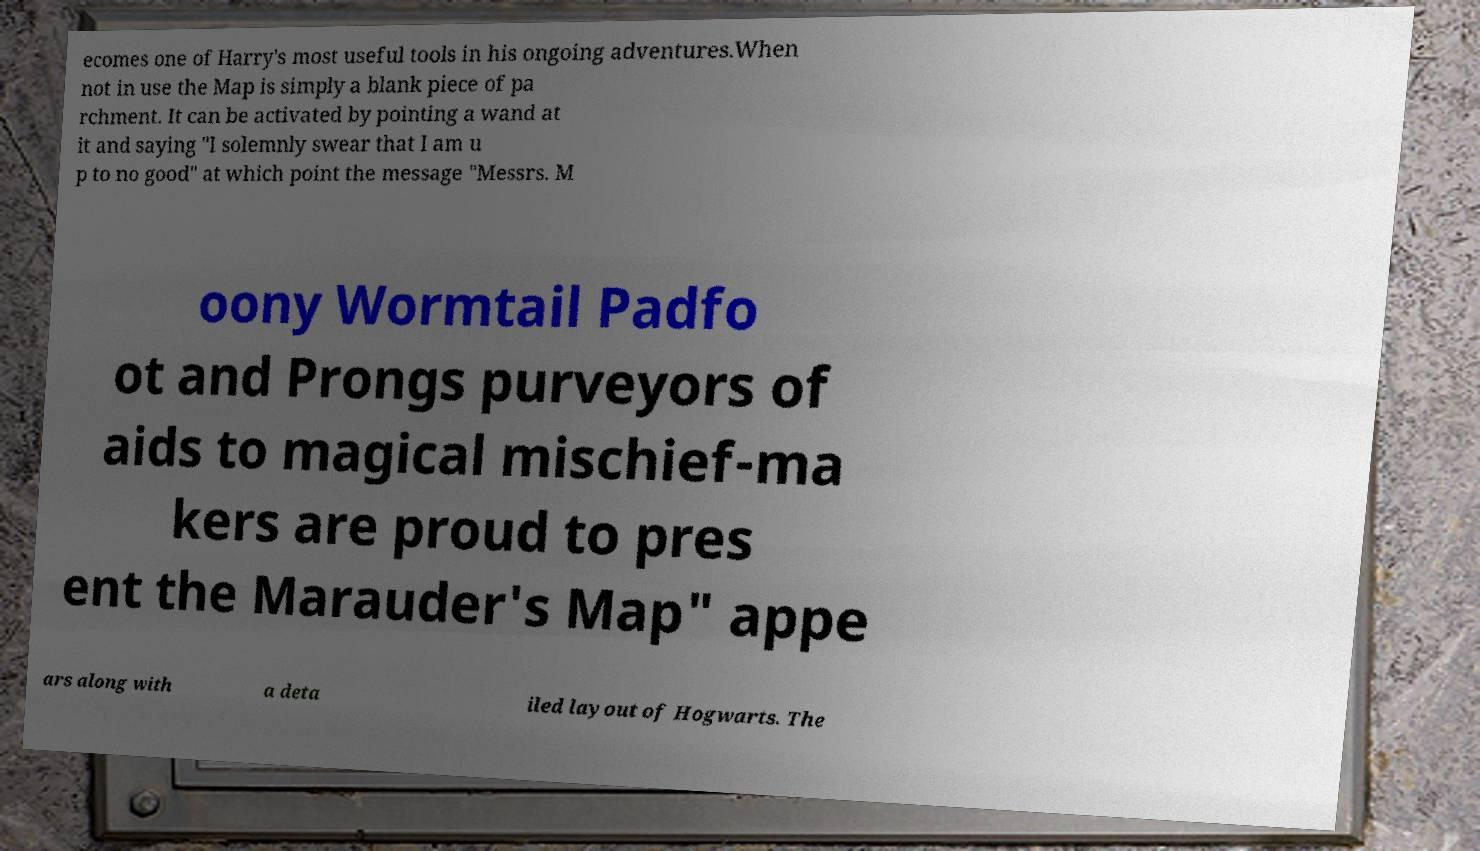For documentation purposes, I need the text within this image transcribed. Could you provide that? ecomes one of Harry's most useful tools in his ongoing adventures.When not in use the Map is simply a blank piece of pa rchment. It can be activated by pointing a wand at it and saying "I solemnly swear that I am u p to no good" at which point the message "Messrs. M oony Wormtail Padfo ot and Prongs purveyors of aids to magical mischief-ma kers are proud to pres ent the Marauder's Map" appe ars along with a deta iled layout of Hogwarts. The 